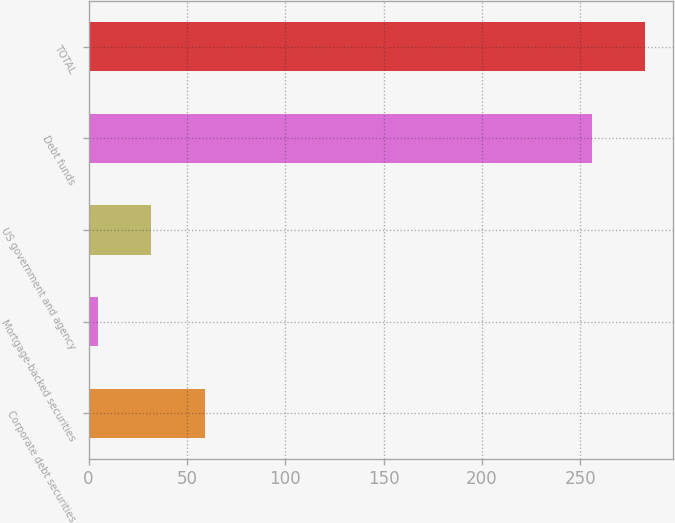Convert chart. <chart><loc_0><loc_0><loc_500><loc_500><bar_chart><fcel>Corporate debt securities<fcel>Mortgage-backed securities<fcel>US government and agency<fcel>Debt funds<fcel>TOTAL<nl><fcel>59<fcel>5<fcel>32<fcel>256<fcel>283<nl></chart> 